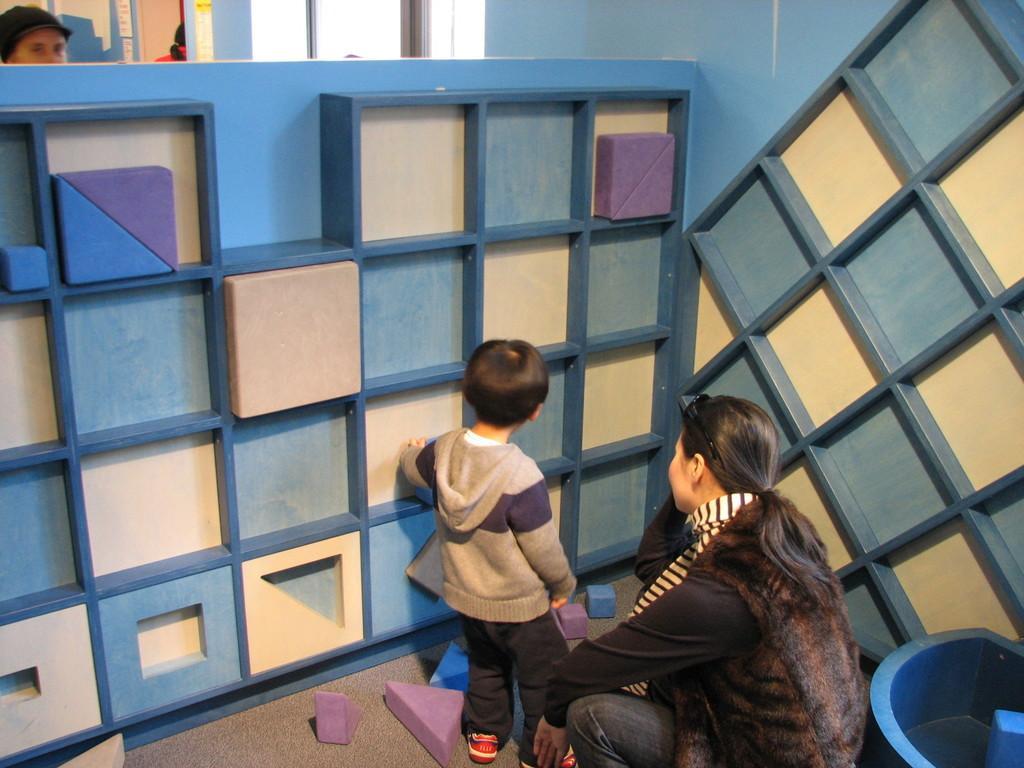Describe this image in one or two sentences. In the center of the image we can see one kid and one woman. And we can see one tub and a few other objects. In the tub, we can see some water. In the background there is a wall, glass, one person standing and wearing a cap, shelves and a few other objects. 